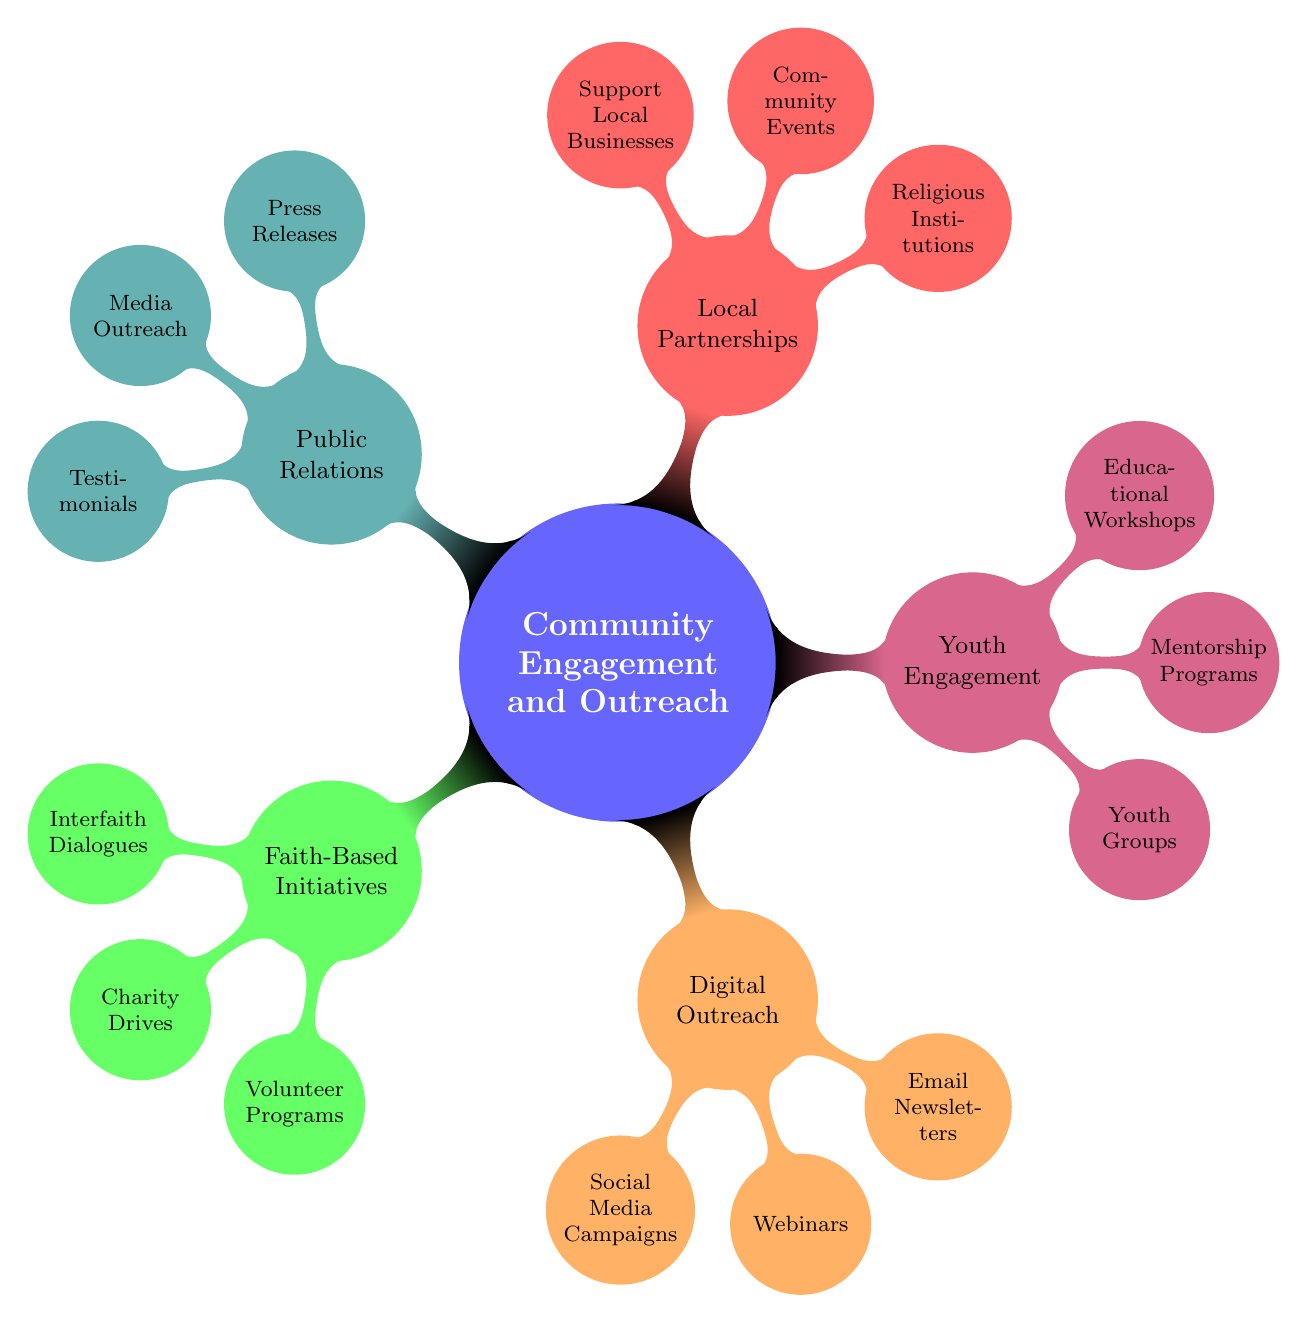What are the main branches of the mind map? The main branches, also known as child nodes, are Faith-Based Initiatives, Digital Outreach, Youth Engagement, Local Partnerships, and Public Relations.
Answer: Faith-Based Initiatives, Digital Outreach, Youth Engagement, Local Partnerships, Public Relations How many initiatives are under Faith-Based Initiatives? There are three initiatives listed under Faith-Based Initiatives: Interfaith Dialogues, Charity Drives, and Volunteer Programs.
Answer: 3 Which branch includes "Social Media Campaigns"? "Social Media Campaigns" is part of the Digital Outreach branch, which focuses on internet-based community engagement strategies.
Answer: Digital Outreach What type of programs does Youth Engagement focus on? Youth Engagement includes initiatives aimed at young people, specifically through Youth Groups, Mentorship Programs, and Educational Workshops.
Answer: Youth Groups, Mentorship Programs, Educational Workshops What is one initiative listed under Local Partnerships? One initiative under Local Partnerships is Collaborations with Religious Institutions, which focuses on working together with local religious entities for community projects.
Answer: Collaborations with Religious Institutions Which two branches contain initiatives related to community events? The branches that contain initiatives related to community events are Local Partnerships (Joint Community Events) and Faith-Based Initiatives (Volunteer Programs).
Answer: Local Partnerships, Faith-Based Initiatives How many total initiatives are mentioned in the mind map? The total number of initiatives mentioned includes 3 from Faith-Based Initiatives, 3 from Digital Outreach, 3 from Youth Engagement, 3 from Local Partnerships, and 3 from Public Relations, which adds up to 15 initiatives.
Answer: 15 What is the focus of the webinars mentioned in Digital Outreach? The webinars in Digital Outreach focus on virtual discussions related to ethical entrepreneurship and faith principles, providing guidance and insights in these areas.
Answer: Ethical entrepreneurship and faith principles Which initiative is aimed at promoting faith-based values on social media? The initiative aimed at promoting faith-based values on social media is the Social Media Campaigns listed under Digital Outreach.
Answer: Social Media Campaigns What type of stories are shared in Public Relations? In Public Relations, Testimonials and Success Stories are shared to highlight the impact of community engagement initiatives, showcasing personal experiences and outcomes.
Answer: Testimonials and Success Stories 